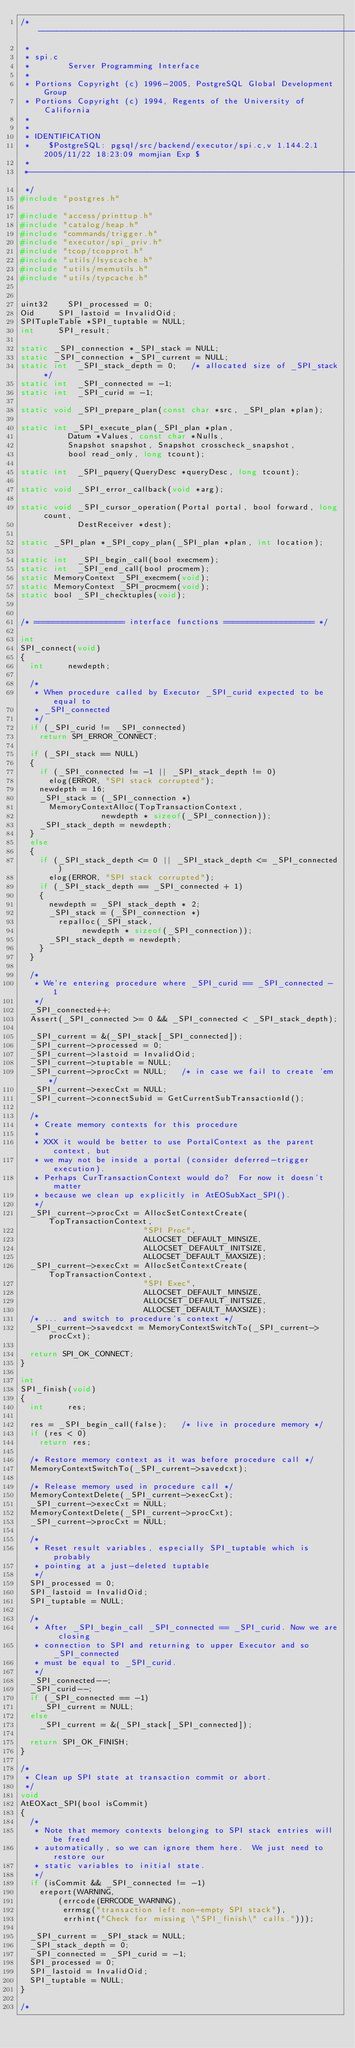Convert code to text. <code><loc_0><loc_0><loc_500><loc_500><_C_>/*-------------------------------------------------------------------------
 *
 * spi.c
 *				Server Programming Interface
 *
 * Portions Copyright (c) 1996-2005, PostgreSQL Global Development Group
 * Portions Copyright (c) 1994, Regents of the University of California
 *
 *
 * IDENTIFICATION
 *	  $PostgreSQL: pgsql/src/backend/executor/spi.c,v 1.144.2.1 2005/11/22 18:23:09 momjian Exp $
 *
 *-------------------------------------------------------------------------
 */
#include "postgres.h"

#include "access/printtup.h"
#include "catalog/heap.h"
#include "commands/trigger.h"
#include "executor/spi_priv.h"
#include "tcop/tcopprot.h"
#include "utils/lsyscache.h"
#include "utils/memutils.h"
#include "utils/typcache.h"


uint32		SPI_processed = 0;
Oid			SPI_lastoid = InvalidOid;
SPITupleTable *SPI_tuptable = NULL;
int			SPI_result;

static _SPI_connection *_SPI_stack = NULL;
static _SPI_connection *_SPI_current = NULL;
static int	_SPI_stack_depth = 0;		/* allocated size of _SPI_stack */
static int	_SPI_connected = -1;
static int	_SPI_curid = -1;

static void _SPI_prepare_plan(const char *src, _SPI_plan *plan);

static int _SPI_execute_plan(_SPI_plan *plan,
				  Datum *Values, const char *Nulls,
				  Snapshot snapshot, Snapshot crosscheck_snapshot,
				  bool read_only, long tcount);

static int	_SPI_pquery(QueryDesc *queryDesc, long tcount);

static void _SPI_error_callback(void *arg);

static void _SPI_cursor_operation(Portal portal, bool forward, long count,
					  DestReceiver *dest);

static _SPI_plan *_SPI_copy_plan(_SPI_plan *plan, int location);

static int	_SPI_begin_call(bool execmem);
static int	_SPI_end_call(bool procmem);
static MemoryContext _SPI_execmem(void);
static MemoryContext _SPI_procmem(void);
static bool _SPI_checktuples(void);


/* =================== interface functions =================== */

int
SPI_connect(void)
{
	int			newdepth;

	/*
	 * When procedure called by Executor _SPI_curid expected to be equal to
	 * _SPI_connected
	 */
	if (_SPI_curid != _SPI_connected)
		return SPI_ERROR_CONNECT;

	if (_SPI_stack == NULL)
	{
		if (_SPI_connected != -1 || _SPI_stack_depth != 0)
			elog(ERROR, "SPI stack corrupted");
		newdepth = 16;
		_SPI_stack = (_SPI_connection *)
			MemoryContextAlloc(TopTransactionContext,
							   newdepth * sizeof(_SPI_connection));
		_SPI_stack_depth = newdepth;
	}
	else
	{
		if (_SPI_stack_depth <= 0 || _SPI_stack_depth <= _SPI_connected)
			elog(ERROR, "SPI stack corrupted");
		if (_SPI_stack_depth == _SPI_connected + 1)
		{
			newdepth = _SPI_stack_depth * 2;
			_SPI_stack = (_SPI_connection *)
				repalloc(_SPI_stack,
						 newdepth * sizeof(_SPI_connection));
			_SPI_stack_depth = newdepth;
		}
	}

	/*
	 * We're entering procedure where _SPI_curid == _SPI_connected - 1
	 */
	_SPI_connected++;
	Assert(_SPI_connected >= 0 && _SPI_connected < _SPI_stack_depth);

	_SPI_current = &(_SPI_stack[_SPI_connected]);
	_SPI_current->processed = 0;
	_SPI_current->lastoid = InvalidOid;
	_SPI_current->tuptable = NULL;
	_SPI_current->procCxt = NULL;		/* in case we fail to create 'em */
	_SPI_current->execCxt = NULL;
	_SPI_current->connectSubid = GetCurrentSubTransactionId();

	/*
	 * Create memory contexts for this procedure
	 *
	 * XXX it would be better to use PortalContext as the parent context, but
	 * we may not be inside a portal (consider deferred-trigger execution).
	 * Perhaps CurTransactionContext would do?	For now it doesn't matter
	 * because we clean up explicitly in AtEOSubXact_SPI().
	 */
	_SPI_current->procCxt = AllocSetContextCreate(TopTransactionContext,
												  "SPI Proc",
												  ALLOCSET_DEFAULT_MINSIZE,
												  ALLOCSET_DEFAULT_INITSIZE,
												  ALLOCSET_DEFAULT_MAXSIZE);
	_SPI_current->execCxt = AllocSetContextCreate(TopTransactionContext,
												  "SPI Exec",
												  ALLOCSET_DEFAULT_MINSIZE,
												  ALLOCSET_DEFAULT_INITSIZE,
												  ALLOCSET_DEFAULT_MAXSIZE);
	/* ... and switch to procedure's context */
	_SPI_current->savedcxt = MemoryContextSwitchTo(_SPI_current->procCxt);

	return SPI_OK_CONNECT;
}

int
SPI_finish(void)
{
	int			res;

	res = _SPI_begin_call(false);		/* live in procedure memory */
	if (res < 0)
		return res;

	/* Restore memory context as it was before procedure call */
	MemoryContextSwitchTo(_SPI_current->savedcxt);

	/* Release memory used in procedure call */
	MemoryContextDelete(_SPI_current->execCxt);
	_SPI_current->execCxt = NULL;
	MemoryContextDelete(_SPI_current->procCxt);
	_SPI_current->procCxt = NULL;

	/*
	 * Reset result variables, especially SPI_tuptable which is probably
	 * pointing at a just-deleted tuptable
	 */
	SPI_processed = 0;
	SPI_lastoid = InvalidOid;
	SPI_tuptable = NULL;

	/*
	 * After _SPI_begin_call _SPI_connected == _SPI_curid. Now we are closing
	 * connection to SPI and returning to upper Executor and so _SPI_connected
	 * must be equal to _SPI_curid.
	 */
	_SPI_connected--;
	_SPI_curid--;
	if (_SPI_connected == -1)
		_SPI_current = NULL;
	else
		_SPI_current = &(_SPI_stack[_SPI_connected]);

	return SPI_OK_FINISH;
}

/*
 * Clean up SPI state at transaction commit or abort.
 */
void
AtEOXact_SPI(bool isCommit)
{
	/*
	 * Note that memory contexts belonging to SPI stack entries will be freed
	 * automatically, so we can ignore them here.  We just need to restore our
	 * static variables to initial state.
	 */
	if (isCommit && _SPI_connected != -1)
		ereport(WARNING,
				(errcode(ERRCODE_WARNING),
				 errmsg("transaction left non-empty SPI stack"),
				 errhint("Check for missing \"SPI_finish\" calls.")));

	_SPI_current = _SPI_stack = NULL;
	_SPI_stack_depth = 0;
	_SPI_connected = _SPI_curid = -1;
	SPI_processed = 0;
	SPI_lastoid = InvalidOid;
	SPI_tuptable = NULL;
}

/*</code> 